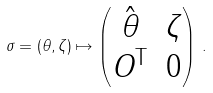Convert formula to latex. <formula><loc_0><loc_0><loc_500><loc_500>\sigma = ( \theta , \zeta ) \mapsto \begin{pmatrix} \hat { \theta } & \zeta \\ O ^ { \text {T} } & 0 \end{pmatrix} \, .</formula> 